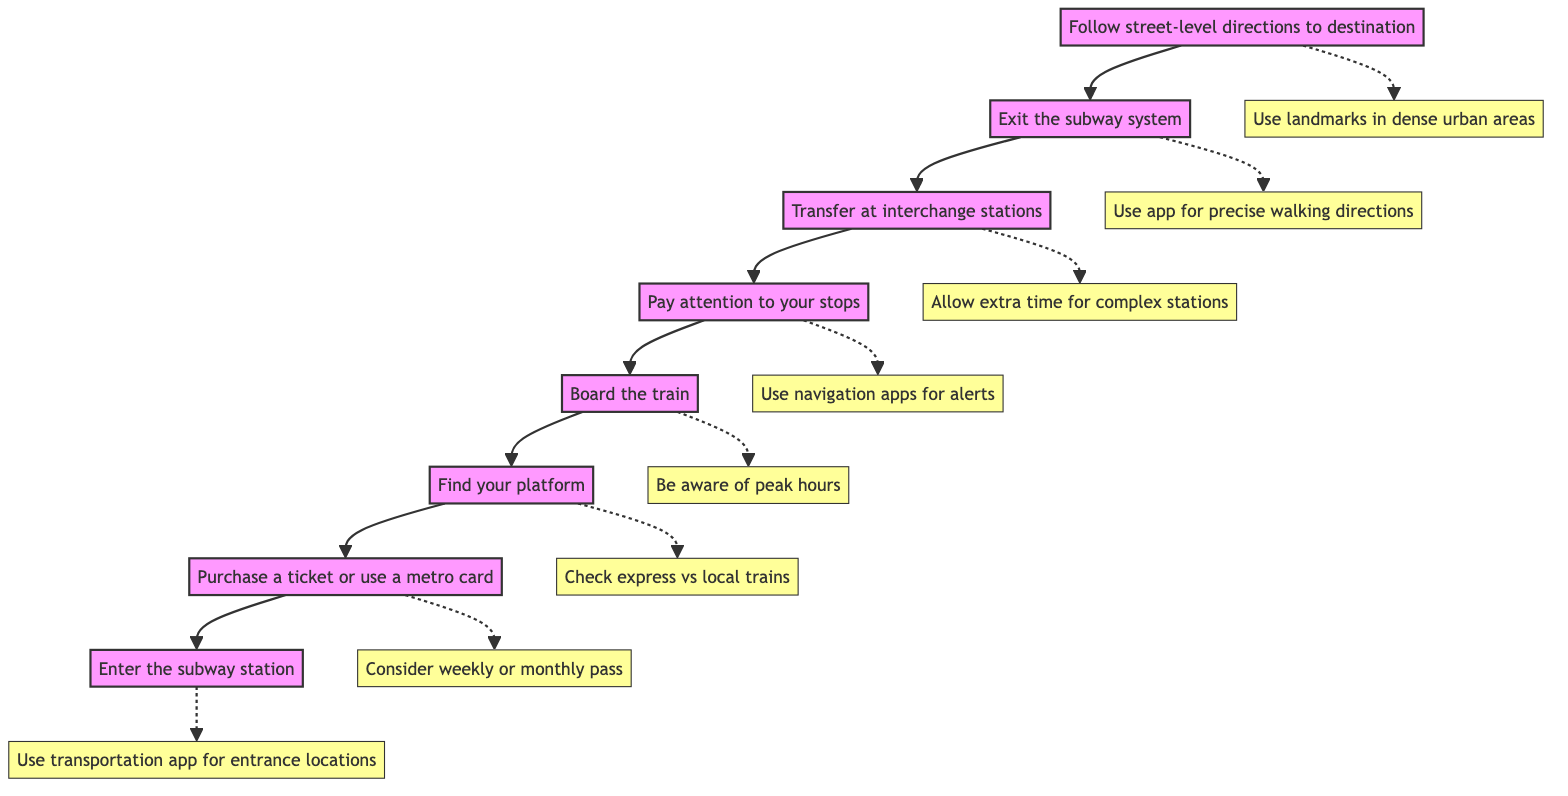What is the first step in this flowchart? The diagram starts with "Enter the subway station," which indicates the initial action a user must take.
Answer: Enter the subway station How many steps are there in total? By counting the main instructional nodes listed in the diagram, there are 8 steps in total.
Answer: 8 What instruction follows "Board the train"? After "Board the train," the next instruction in the flowchart is "Pay attention to your stops."
Answer: Pay attention to your stops What is the last action to take according to the diagram? The final instruction listed in the flowchart is "Follow street-level directions to destination," indicating the last action to perform.
Answer: Follow street-level directions to destination Which instruction comes before "Transfer at interchange stations"? The step right before "Transfer at interchange stations" is "Pay attention to your stops," which signifies that one must be aware of their stops before making any transfers.
Answer: Pay attention to your stops How can one find their platform? According to the diagram, one can find their platform by checking the electronic boards or wall maps, as indicated in the details of the "Find your platform" step.
Answer: Check electronic boards or wall maps Which note suggests using a navigation app for walking directions after exiting? The note associated with "Exit the subway system" states to "Use your navigation app for precise walking directions after exiting," suggesting the use of an app for this purpose.
Answer: Use your navigation app for precise walking directions What should one do at busy stations like Times Square? The note for "Transfer at interchange stations" advises to "Allow extra time for complex stations," indicating that one should plan for additional navigation time in these busy areas.
Answer: Allow extra time for complex stations 